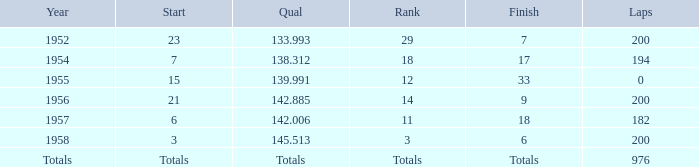In what location did jimmy reece initiate when he held the 12th rank? 15.0. 